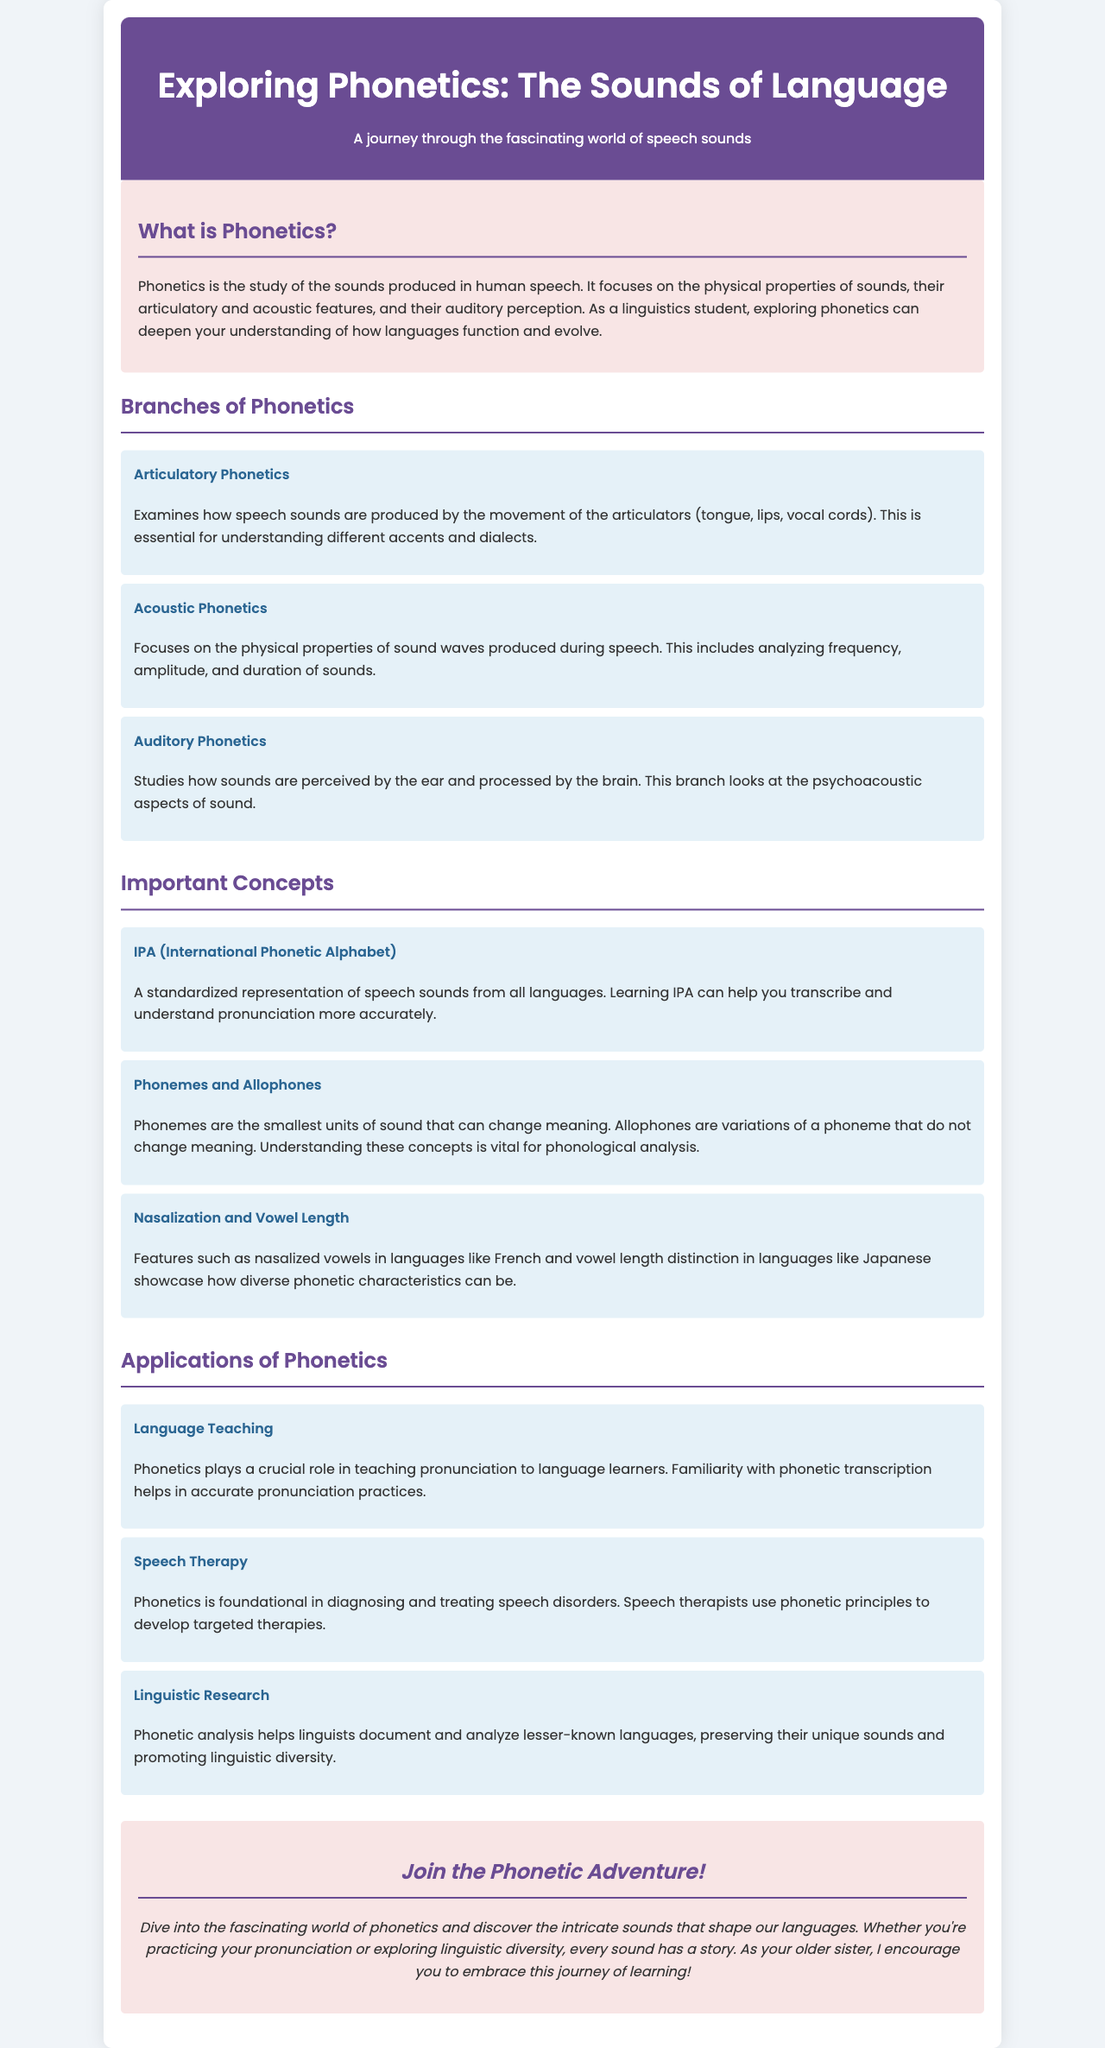What is the focus of phonetics? Phonetics focuses on the physical properties of sounds, their articulatory and acoustic features, and their auditory perception.
Answer: Physical properties of sounds What are the three branches of phonetics? The document lists articulatory, acoustic, and auditory phonetics as the three branches.
Answer: Articulatory, Acoustic, Auditory What does IPA stand for? IPA is an abbreviation for International Phonetic Alphabet, which standardizes the representation of speech sounds.
Answer: International Phonetic Alphabet How does phonetics assist in language teaching? Phonetics plays a crucial role in teaching pronunciation to language learners by aiding in accurate pronunciation practices.
Answer: Teaching pronunciation Name one application of phonetics in speech therapy. In speech therapy, phonetics is foundational in diagnosing and treating speech disorders.
Answer: Diagnosing and treating speech disorders What is the smallest unit of sound that can change meaning? The smallest unit of sound that can change meaning in phonetics is known as a phoneme.
Answer: Phoneme Which language features nasalized vowels? The document mentions that French has nasalized vowels as a phonetic characteristic.
Answer: French What characteristic distinguishes vowel length? Vowel length is distinguished in languages like Japanese, as highlighted in the document.
Answer: Japanese What aspect of sound does acoustic phonetics analyze? Acoustic phonetics analyzes the physical properties of sound waves produced during speech.
Answer: Physical properties of sound waves 